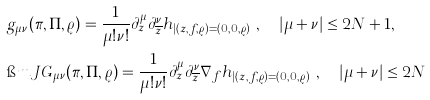<formula> <loc_0><loc_0><loc_500><loc_500>& g _ { \mu \nu } ( \pi , \Pi , \varrho ) = \frac { 1 } { \mu ! \nu ! } \partial _ { z } ^ { \mu } \partial _ { \overline { z } } ^ { \nu } h _ { | ( z , f , \varrho ) = ( 0 , 0 , \varrho ) } \ , \quad | \mu + \nu | \leq 2 { N } + 1 , \\ & \i m J G _ { \mu \nu } ( \pi , \Pi , \varrho ) = \frac { 1 } { \mu ! \nu ! } \partial _ { z } ^ { \mu } \partial _ { \overline { z } } ^ { \nu } \nabla _ { f } h _ { | ( z , f , \varrho ) = ( 0 , 0 , \varrho ) } \ , \quad | \mu + \nu | \leq 2 { N }</formula> 